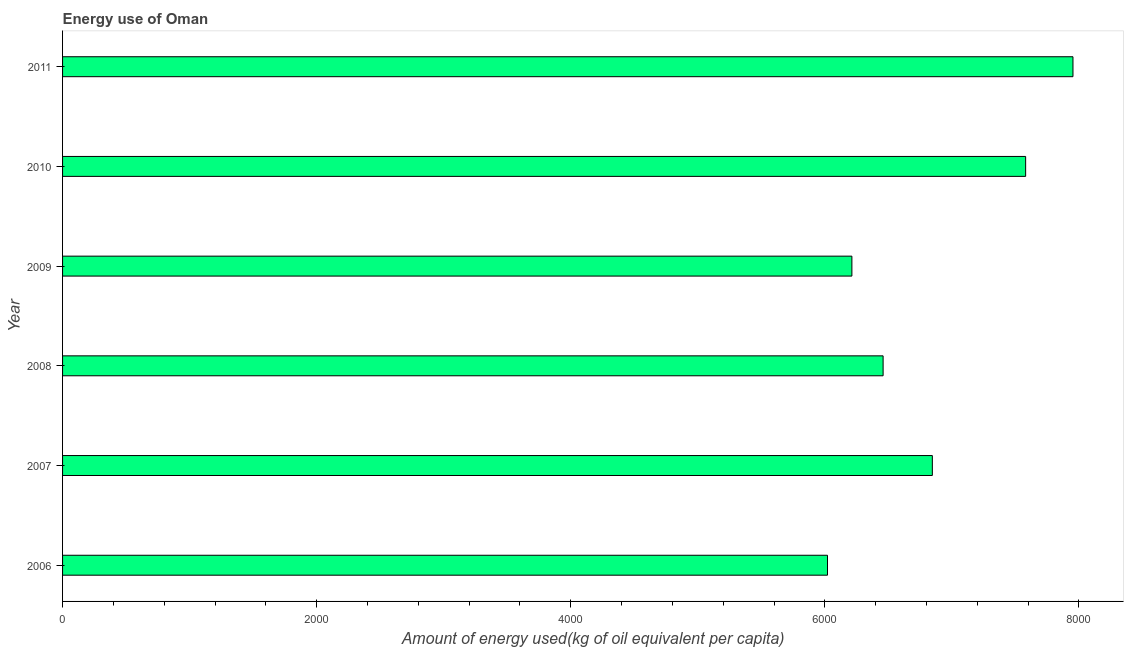What is the title of the graph?
Your answer should be compact. Energy use of Oman. What is the label or title of the X-axis?
Ensure brevity in your answer.  Amount of energy used(kg of oil equivalent per capita). What is the label or title of the Y-axis?
Ensure brevity in your answer.  Year. What is the amount of energy used in 2010?
Your answer should be compact. 7580.61. Across all years, what is the maximum amount of energy used?
Offer a very short reply. 7953.18. Across all years, what is the minimum amount of energy used?
Ensure brevity in your answer.  6020.96. In which year was the amount of energy used maximum?
Ensure brevity in your answer.  2011. In which year was the amount of energy used minimum?
Provide a succinct answer. 2006. What is the sum of the amount of energy used?
Provide a succinct answer. 4.11e+04. What is the difference between the amount of energy used in 2006 and 2010?
Ensure brevity in your answer.  -1559.65. What is the average amount of energy used per year?
Offer a very short reply. 6845.44. What is the median amount of energy used?
Offer a very short reply. 6652.47. In how many years, is the amount of energy used greater than 3600 kg?
Offer a very short reply. 6. Do a majority of the years between 2008 and 2010 (inclusive) have amount of energy used greater than 7600 kg?
Offer a very short reply. No. What is the ratio of the amount of energy used in 2008 to that in 2010?
Provide a succinct answer. 0.85. Is the amount of energy used in 2006 less than that in 2007?
Provide a succinct answer. Yes. Is the difference between the amount of energy used in 2009 and 2010 greater than the difference between any two years?
Give a very brief answer. No. What is the difference between the highest and the second highest amount of energy used?
Your response must be concise. 372.57. What is the difference between the highest and the lowest amount of energy used?
Your answer should be very brief. 1932.22. How many bars are there?
Your answer should be compact. 6. How many years are there in the graph?
Give a very brief answer. 6. What is the Amount of energy used(kg of oil equivalent per capita) of 2006?
Your answer should be compact. 6020.96. What is the Amount of energy used(kg of oil equivalent per capita) in 2007?
Make the answer very short. 6846.24. What is the Amount of energy used(kg of oil equivalent per capita) of 2008?
Give a very brief answer. 6458.7. What is the Amount of energy used(kg of oil equivalent per capita) in 2009?
Provide a succinct answer. 6212.94. What is the Amount of energy used(kg of oil equivalent per capita) of 2010?
Give a very brief answer. 7580.61. What is the Amount of energy used(kg of oil equivalent per capita) in 2011?
Keep it short and to the point. 7953.18. What is the difference between the Amount of energy used(kg of oil equivalent per capita) in 2006 and 2007?
Your answer should be very brief. -825.28. What is the difference between the Amount of energy used(kg of oil equivalent per capita) in 2006 and 2008?
Keep it short and to the point. -437.75. What is the difference between the Amount of energy used(kg of oil equivalent per capita) in 2006 and 2009?
Offer a terse response. -191.99. What is the difference between the Amount of energy used(kg of oil equivalent per capita) in 2006 and 2010?
Ensure brevity in your answer.  -1559.65. What is the difference between the Amount of energy used(kg of oil equivalent per capita) in 2006 and 2011?
Your answer should be very brief. -1932.22. What is the difference between the Amount of energy used(kg of oil equivalent per capita) in 2007 and 2008?
Give a very brief answer. 387.54. What is the difference between the Amount of energy used(kg of oil equivalent per capita) in 2007 and 2009?
Make the answer very short. 633.3. What is the difference between the Amount of energy used(kg of oil equivalent per capita) in 2007 and 2010?
Your answer should be compact. -734.37. What is the difference between the Amount of energy used(kg of oil equivalent per capita) in 2007 and 2011?
Make the answer very short. -1106.94. What is the difference between the Amount of energy used(kg of oil equivalent per capita) in 2008 and 2009?
Provide a succinct answer. 245.76. What is the difference between the Amount of energy used(kg of oil equivalent per capita) in 2008 and 2010?
Provide a short and direct response. -1121.9. What is the difference between the Amount of energy used(kg of oil equivalent per capita) in 2008 and 2011?
Give a very brief answer. -1494.48. What is the difference between the Amount of energy used(kg of oil equivalent per capita) in 2009 and 2010?
Your response must be concise. -1367.66. What is the difference between the Amount of energy used(kg of oil equivalent per capita) in 2009 and 2011?
Provide a succinct answer. -1740.23. What is the difference between the Amount of energy used(kg of oil equivalent per capita) in 2010 and 2011?
Your answer should be compact. -372.57. What is the ratio of the Amount of energy used(kg of oil equivalent per capita) in 2006 to that in 2007?
Give a very brief answer. 0.88. What is the ratio of the Amount of energy used(kg of oil equivalent per capita) in 2006 to that in 2008?
Ensure brevity in your answer.  0.93. What is the ratio of the Amount of energy used(kg of oil equivalent per capita) in 2006 to that in 2010?
Make the answer very short. 0.79. What is the ratio of the Amount of energy used(kg of oil equivalent per capita) in 2006 to that in 2011?
Provide a succinct answer. 0.76. What is the ratio of the Amount of energy used(kg of oil equivalent per capita) in 2007 to that in 2008?
Provide a short and direct response. 1.06. What is the ratio of the Amount of energy used(kg of oil equivalent per capita) in 2007 to that in 2009?
Keep it short and to the point. 1.1. What is the ratio of the Amount of energy used(kg of oil equivalent per capita) in 2007 to that in 2010?
Give a very brief answer. 0.9. What is the ratio of the Amount of energy used(kg of oil equivalent per capita) in 2007 to that in 2011?
Offer a very short reply. 0.86. What is the ratio of the Amount of energy used(kg of oil equivalent per capita) in 2008 to that in 2010?
Your answer should be compact. 0.85. What is the ratio of the Amount of energy used(kg of oil equivalent per capita) in 2008 to that in 2011?
Ensure brevity in your answer.  0.81. What is the ratio of the Amount of energy used(kg of oil equivalent per capita) in 2009 to that in 2010?
Offer a terse response. 0.82. What is the ratio of the Amount of energy used(kg of oil equivalent per capita) in 2009 to that in 2011?
Your response must be concise. 0.78. What is the ratio of the Amount of energy used(kg of oil equivalent per capita) in 2010 to that in 2011?
Your answer should be very brief. 0.95. 